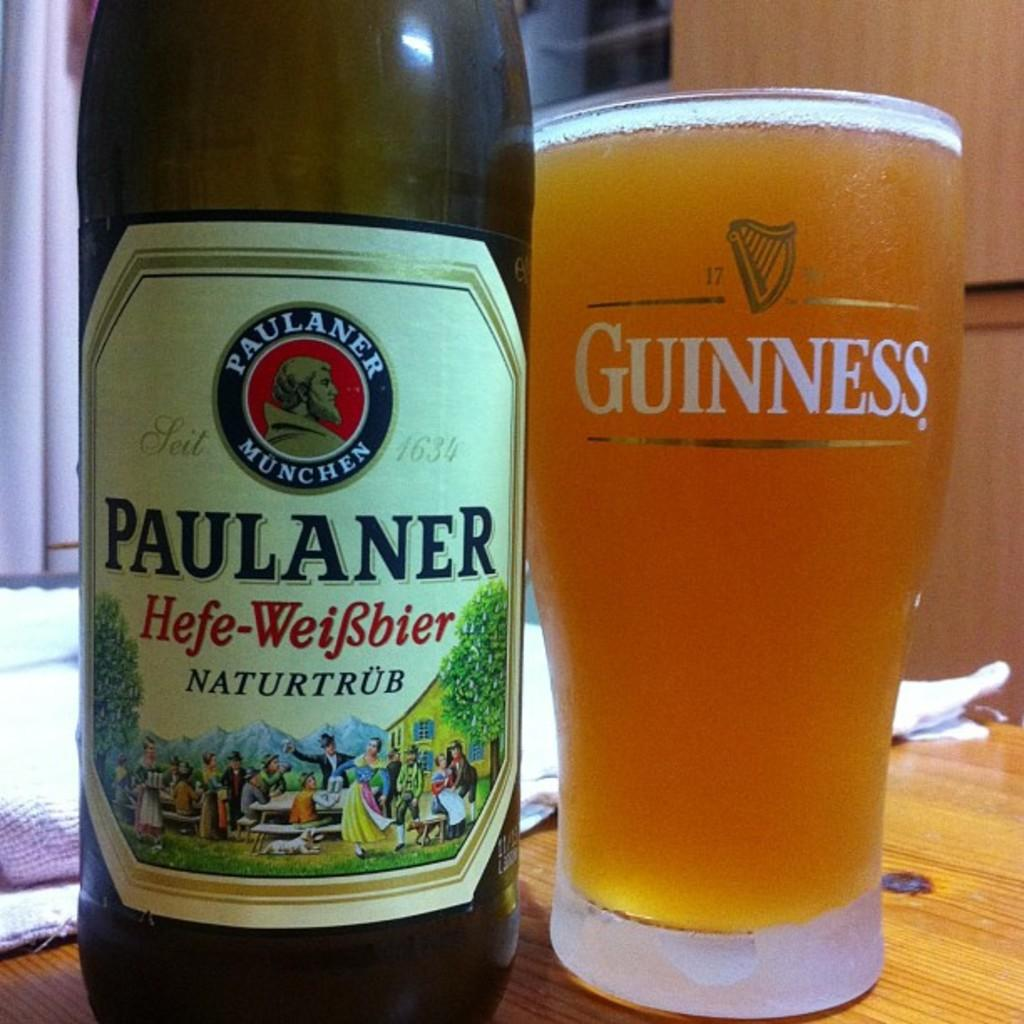Provide a one-sentence caption for the provided image. Paulaner Munchen beer has been poured into a Guinness glass. 